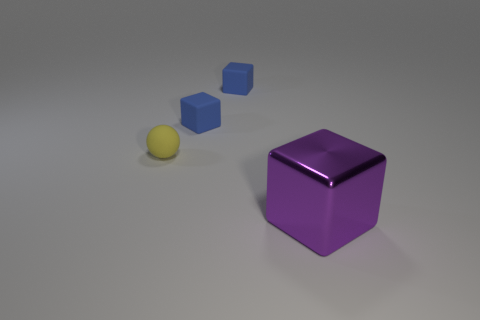Could you infer the material or texture of the objects depicted? Based on the image, the purple cube in the foreground appears to have a somewhat glossy or reflective texture, suggesting a polished, possibly plastic or metallic surface. The blue cubes have a matte finish, also suggesting a non-metallic, possibly plastic or wooden material. The tiny rubber ball looks like it has a matte texture, indicative of rubber or a similar material. 